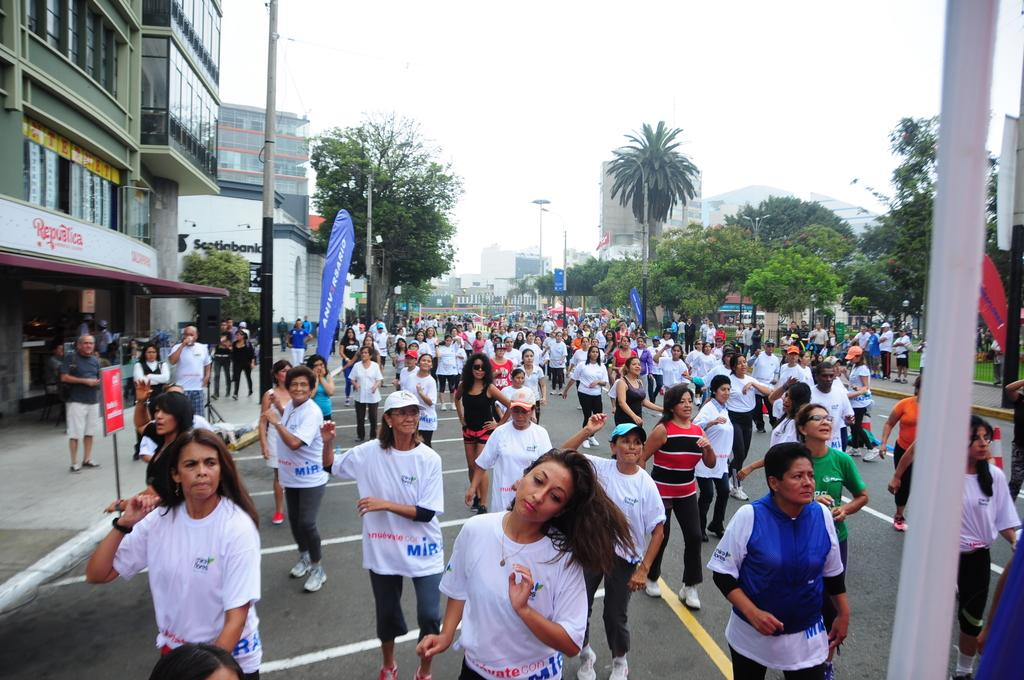Who or what can be seen in the image? There are people in the image. What structures are present in the image? There are poles, banners, boards, trees, and buildings in the image. What can be seen in the background of the image? The sky is visible in the background of the image. What type of riddle is being solved by the people in the image? There is no indication in the image that the people are solving a riddle, so it cannot be determined from the picture. 